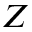Convert formula to latex. <formula><loc_0><loc_0><loc_500><loc_500>Z</formula> 